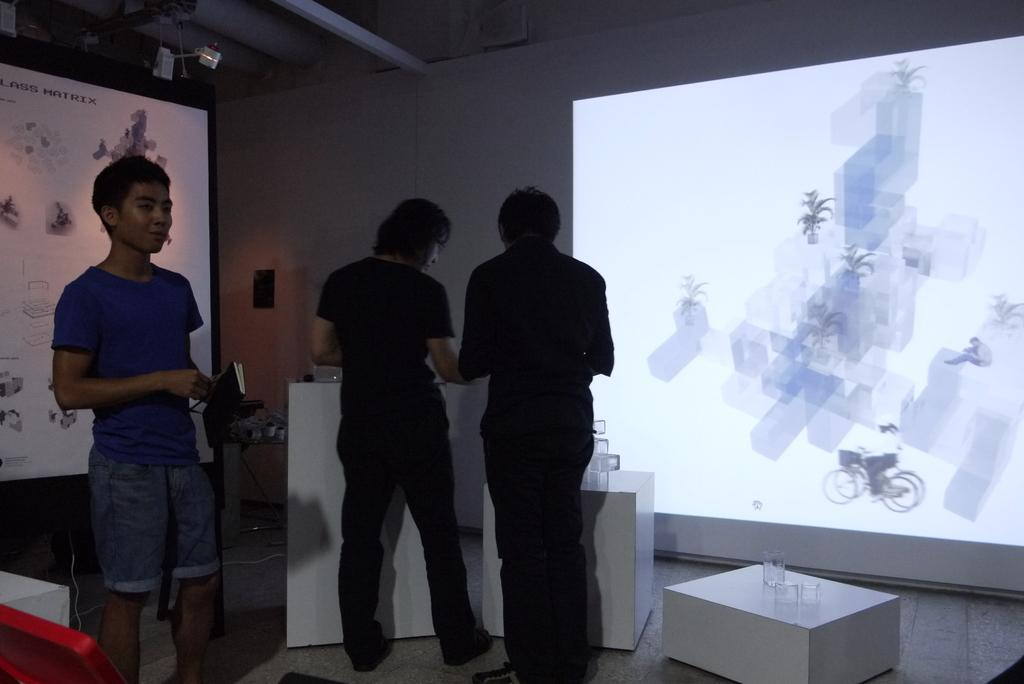How many people are in the image? There is a group of persons standing in the image. What can be seen in the background of the image? There is a screen, light, and a hoarding in the background of the image. What object is on a table in the image? There is a glass object on a table in the image. What type of insurance policy is being discussed by the group in the image? There is no indication in the image that the group is discussing any insurance policies. 